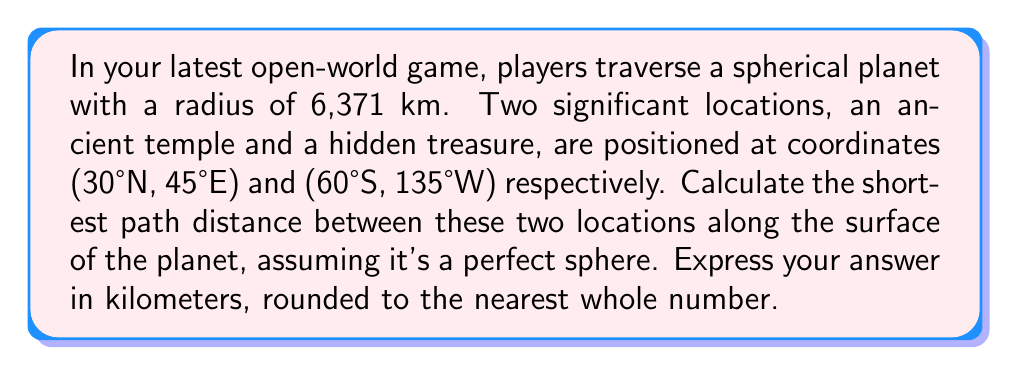What is the answer to this math problem? To solve this problem, we'll use the concept of geodesics on a sphere, which are great circles. The shortest path between two points on a sphere always lies on a great circle. We'll use the haversine formula to calculate the central angle between the two points, then use this angle to determine the arc length along the great circle.

Step 1: Convert the coordinates to radians.
Let $(φ_1, λ_1)$ be the coordinates of the temple and $(φ_2, λ_2)$ be the coordinates of the treasure.

$φ_1 = 30° \cdot \frac{\pi}{180} = 0.5236$ rad
$λ_1 = 45° \cdot \frac{\pi}{180} = 0.7854$ rad
$φ_2 = -60° \cdot \frac{\pi}{180} = -1.0472$ rad
$λ_2 = -135° \cdot \frac{\pi}{180} = -2.3562$ rad

Step 2: Calculate the difference in longitude.
$Δλ = λ_2 - λ_1 = -2.3562 - 0.7854 = -3.1416$ rad

Step 3: Apply the haversine formula to find the central angle θ.

$$\begin{align*}
a &= \sin^2\left(\frac{φ_2 - φ_1}{2}\right) + \cos(φ_1)\cos(φ_2)\sin^2\left(\frac{Δλ}{2}\right) \\
&= \sin^2\left(\frac{-1.0472 - 0.5236}{2}\right) + \cos(0.5236)\cos(-1.0472)\sin^2\left(\frac{-3.1416}{2}\right) \\
&= 0.3750 + 0.4665 \cdot 0.5000 \cdot 1.0000 \\
&= 0.6083
\end{align*}$$

$$θ = 2 \arcsin(\sqrt{a}) = 2 \arcsin(\sqrt{0.6083}) = 2.0944 \text{ rad}$$

Step 4: Calculate the arc length using the radius of the planet.
$$d = R \cdot θ = 6371 \cdot 2.0944 = 13,343.97 \text{ km}$$

Step 5: Round to the nearest whole number.
$13,344 \text{ km}$
Answer: The shortest path distance between the ancient temple and the hidden treasure is 13,344 km. 